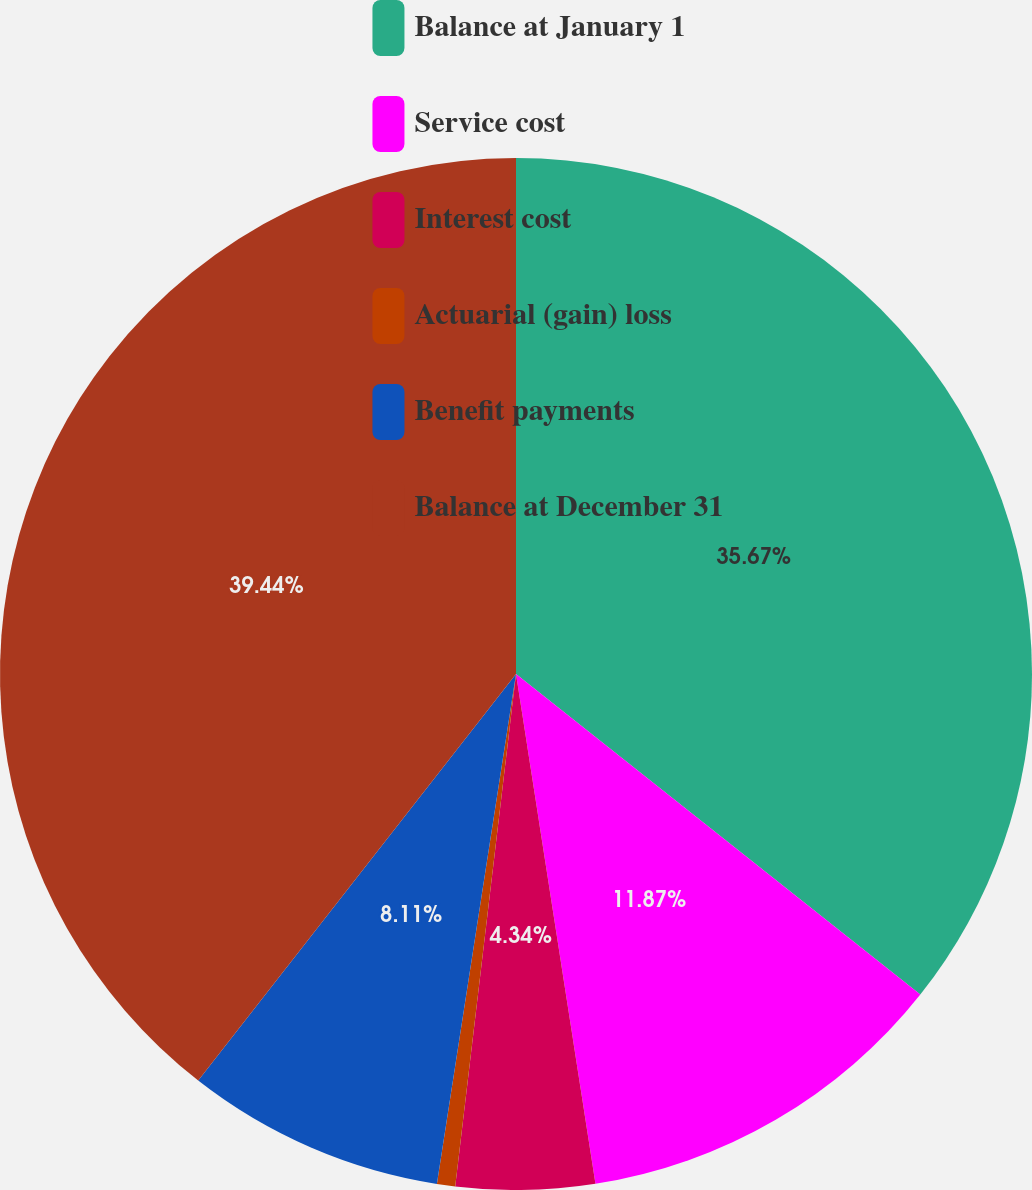Convert chart to OTSL. <chart><loc_0><loc_0><loc_500><loc_500><pie_chart><fcel>Balance at January 1<fcel>Service cost<fcel>Interest cost<fcel>Actuarial (gain) loss<fcel>Benefit payments<fcel>Balance at December 31<nl><fcel>35.67%<fcel>11.87%<fcel>4.34%<fcel>0.57%<fcel>8.11%<fcel>39.44%<nl></chart> 